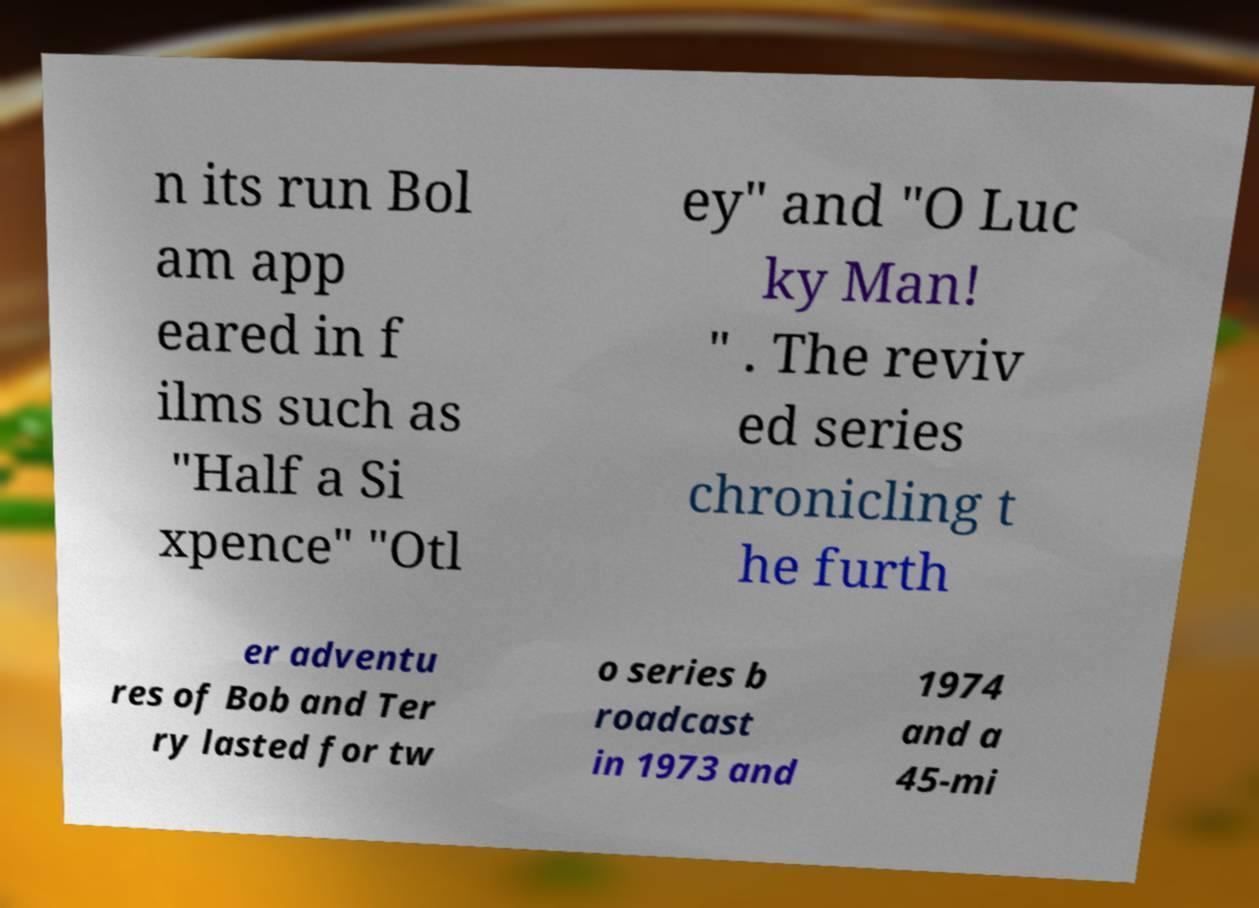Could you assist in decoding the text presented in this image and type it out clearly? n its run Bol am app eared in f ilms such as "Half a Si xpence" "Otl ey" and "O Luc ky Man! " . The reviv ed series chronicling t he furth er adventu res of Bob and Ter ry lasted for tw o series b roadcast in 1973 and 1974 and a 45-mi 